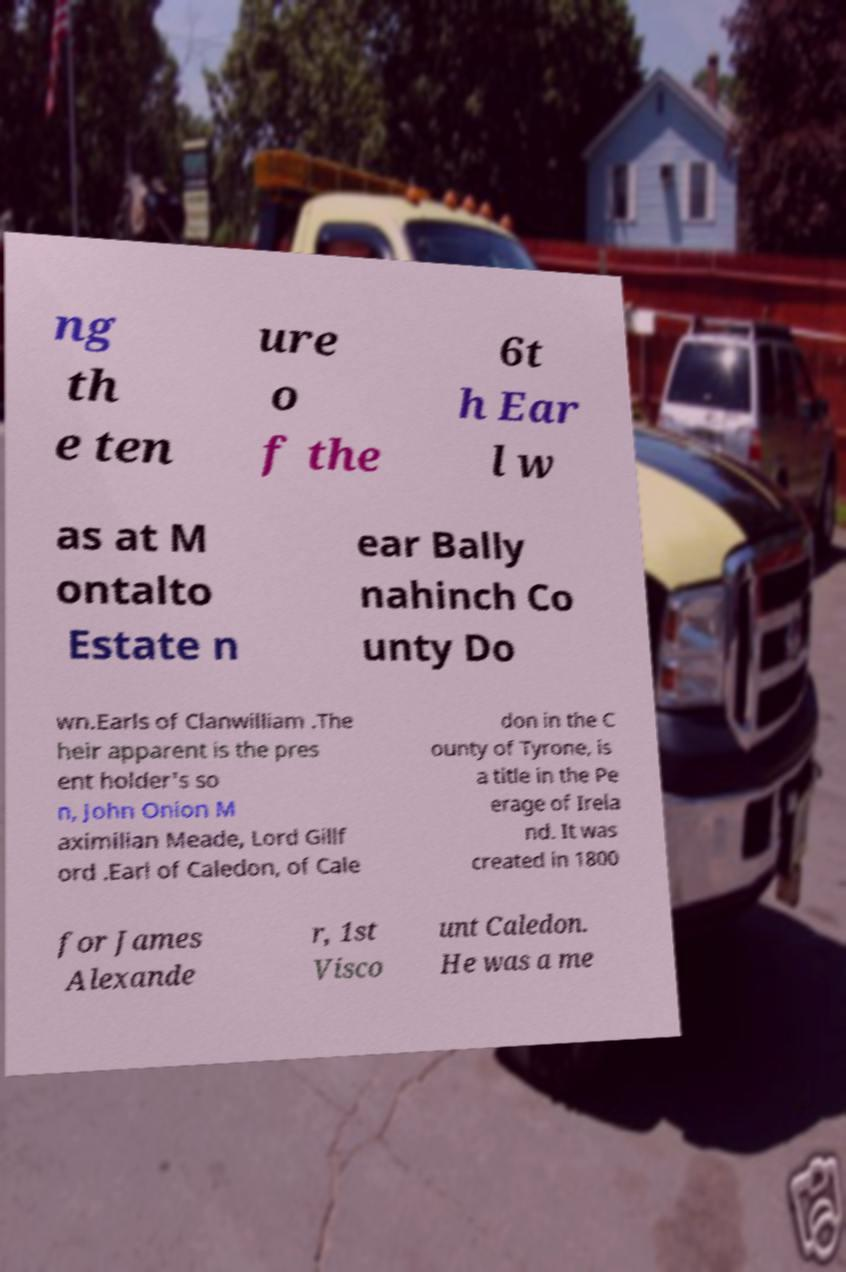There's text embedded in this image that I need extracted. Can you transcribe it verbatim? ng th e ten ure o f the 6t h Ear l w as at M ontalto Estate n ear Bally nahinch Co unty Do wn.Earls of Clanwilliam .The heir apparent is the pres ent holder's so n, John Onion M aximilian Meade, Lord Gillf ord .Earl of Caledon, of Cale don in the C ounty of Tyrone, is a title in the Pe erage of Irela nd. It was created in 1800 for James Alexande r, 1st Visco unt Caledon. He was a me 